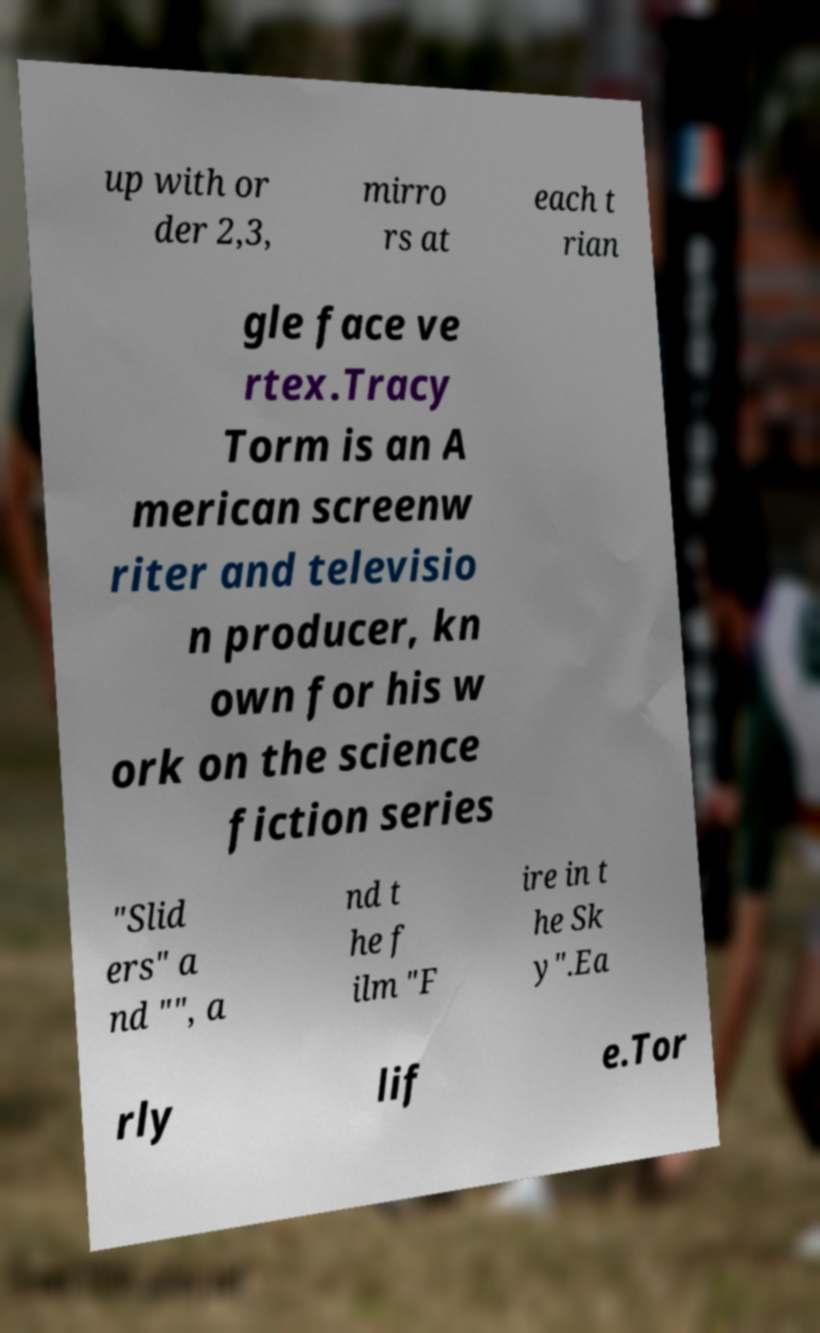What messages or text are displayed in this image? I need them in a readable, typed format. up with or der 2,3, mirro rs at each t rian gle face ve rtex.Tracy Torm is an A merican screenw riter and televisio n producer, kn own for his w ork on the science fiction series "Slid ers" a nd "", a nd t he f ilm "F ire in t he Sk y".Ea rly lif e.Tor 